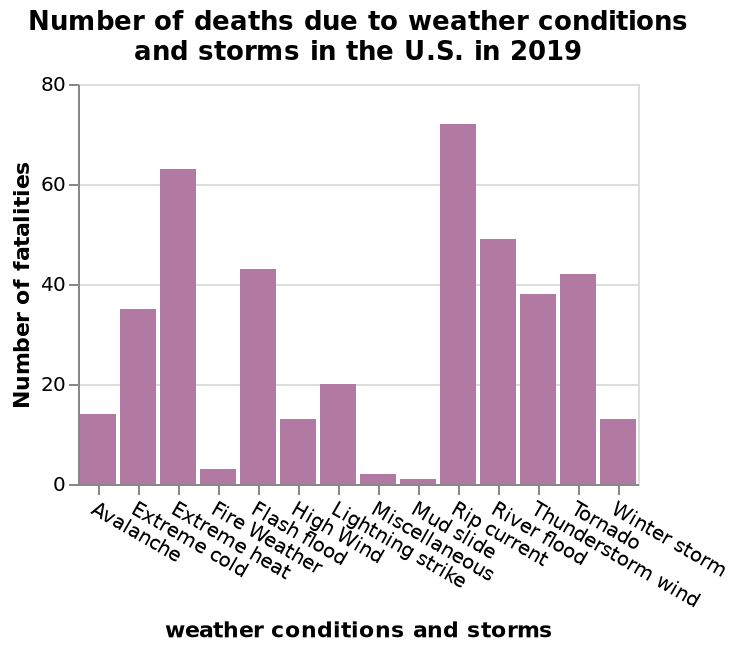<image>
What are two of the most dangerous weather conditions mentioned in the figure?  Rip currents and extreme heat. What is the specific focus of the bar diagram?  The bar diagram focuses on the number of deaths due to weather conditions and storms in the U.S. in 2019. What are the dangers associated with extreme heat? Extreme heat is considered one of the most dangerous weather conditions. 